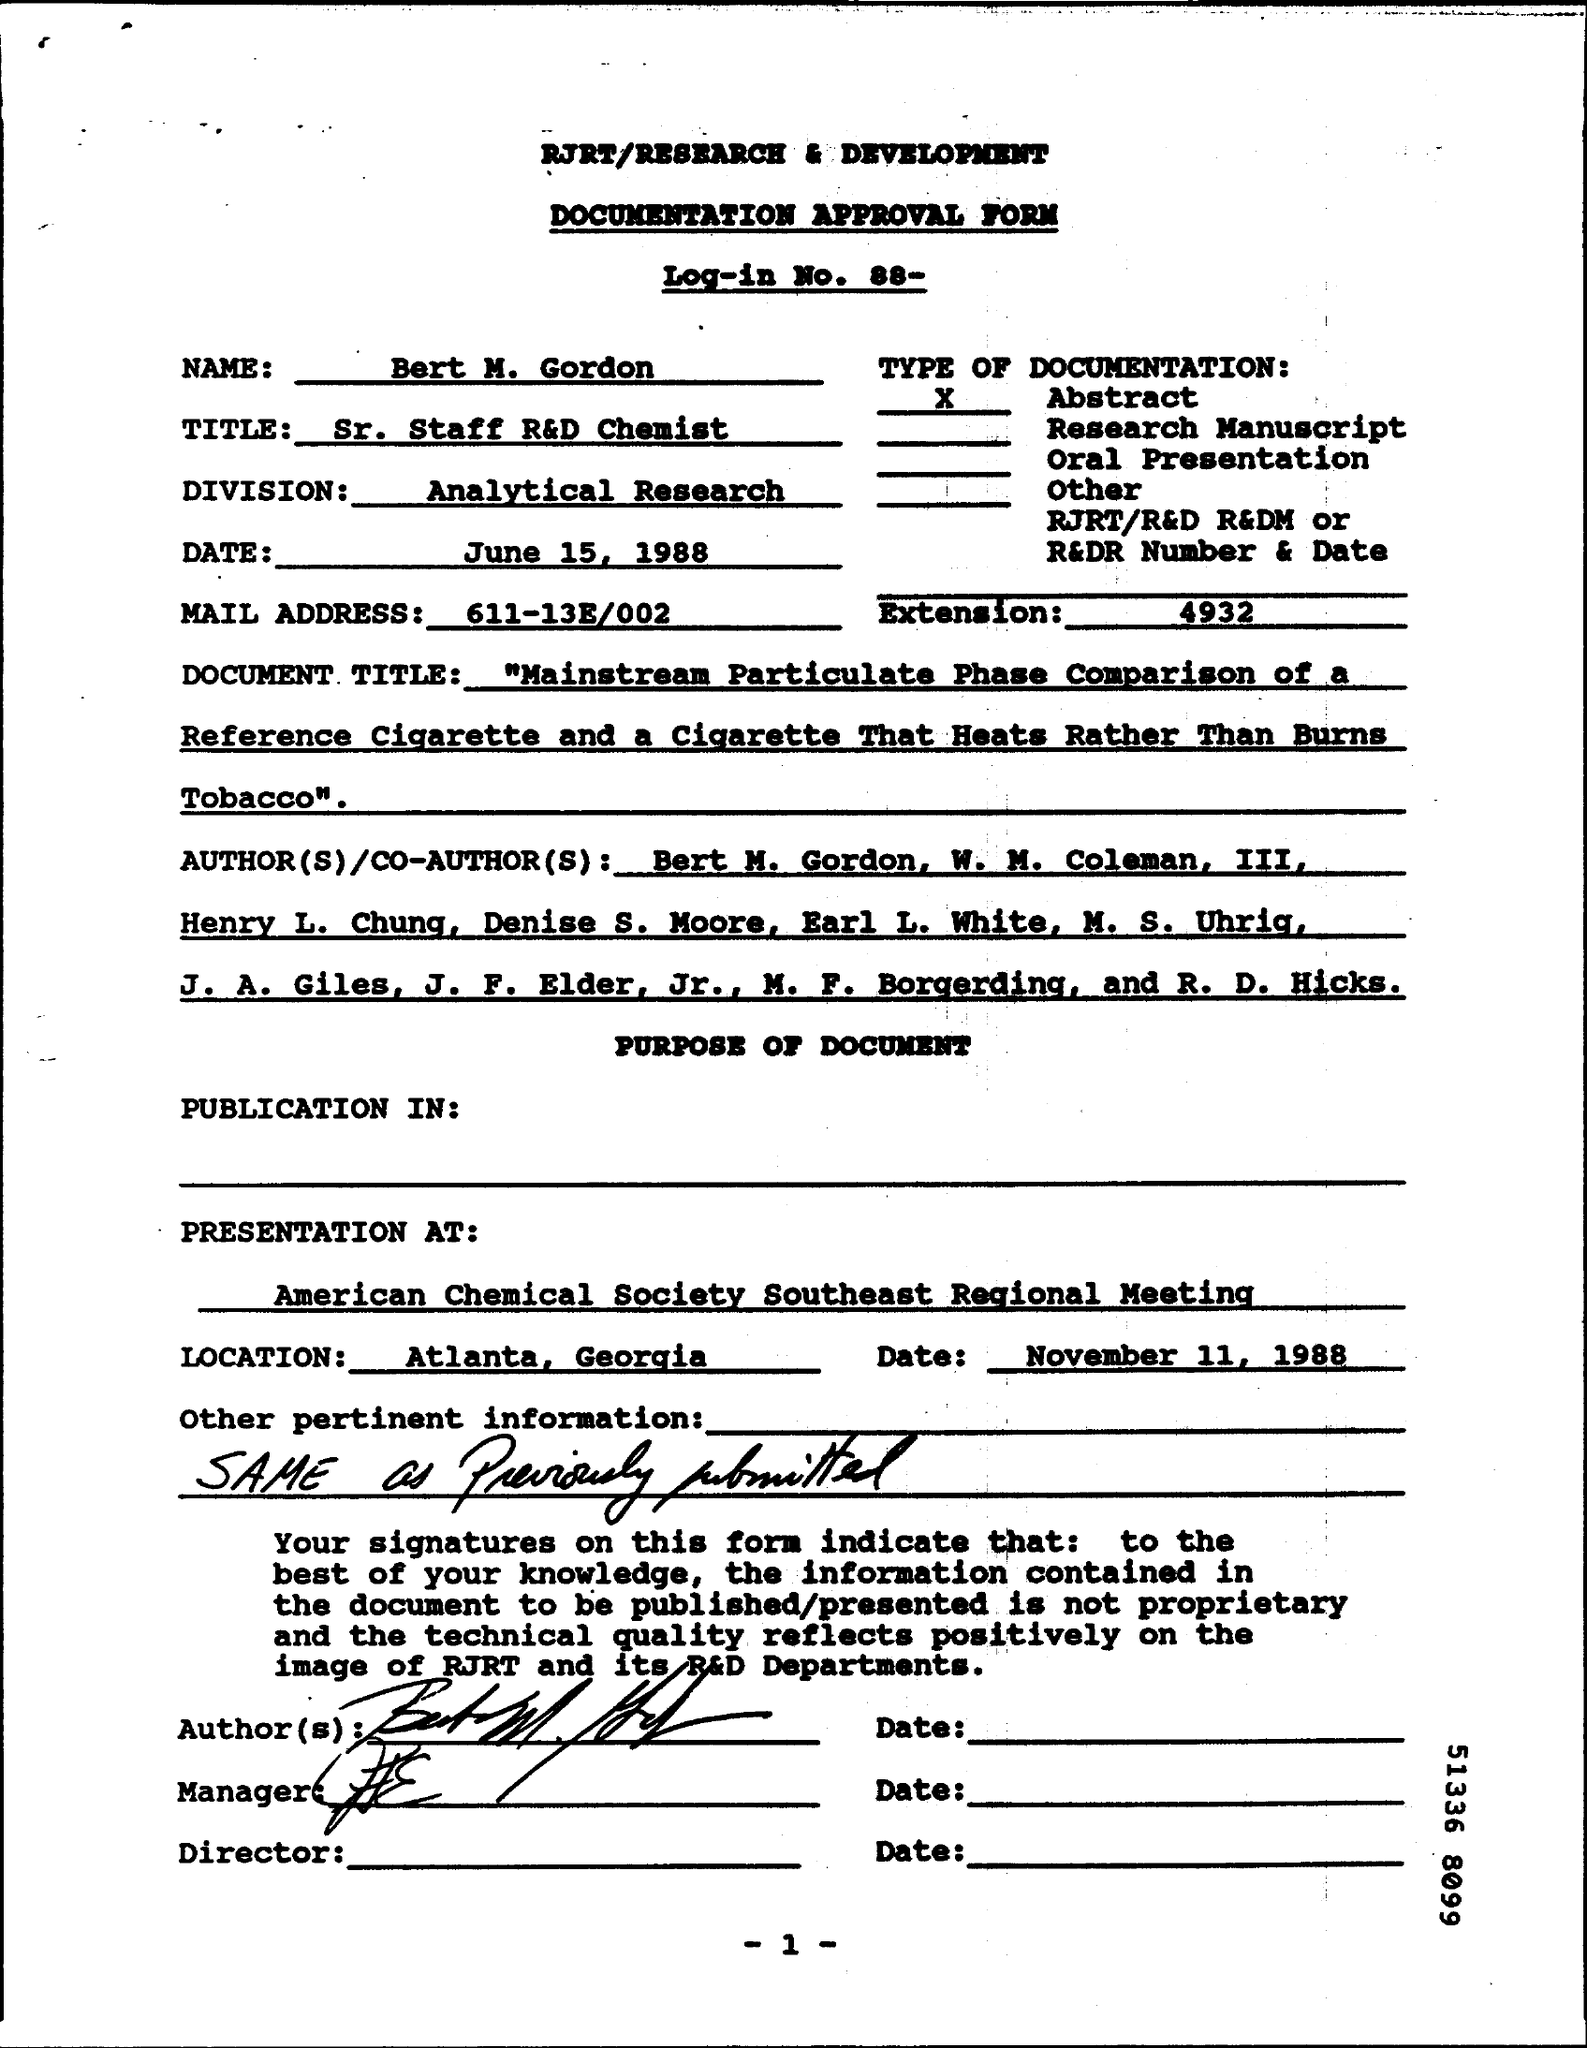List a handful of essential elements in this visual. This is a documentation approval form. On November 11, 1988, the presentation took place. The document is dated June 15, 1988. Bert holds the position of Sr. Staff R&D Chemist. I, [name], hereby declare that the type of documentation is abstract. 